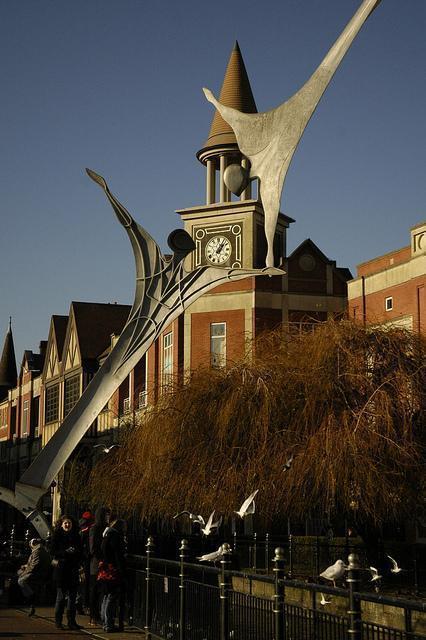How many people are visible?
Give a very brief answer. 2. 